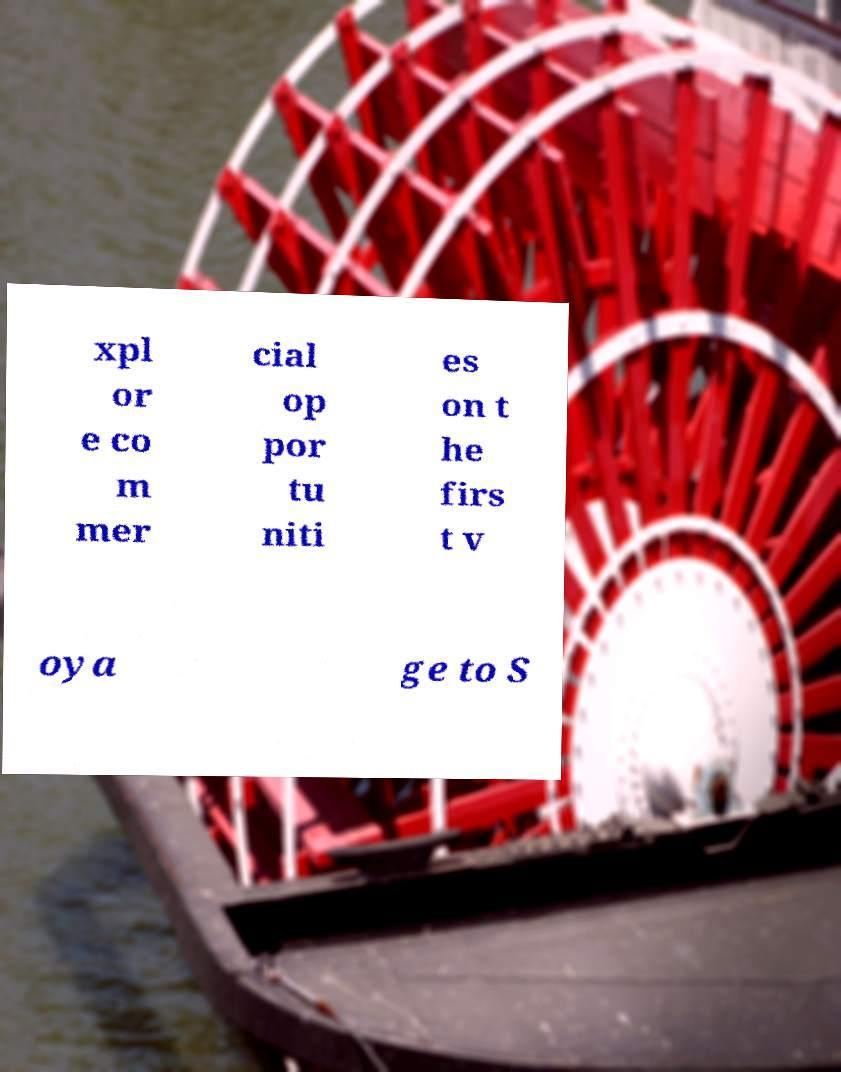I need the written content from this picture converted into text. Can you do that? xpl or e co m mer cial op por tu niti es on t he firs t v oya ge to S 